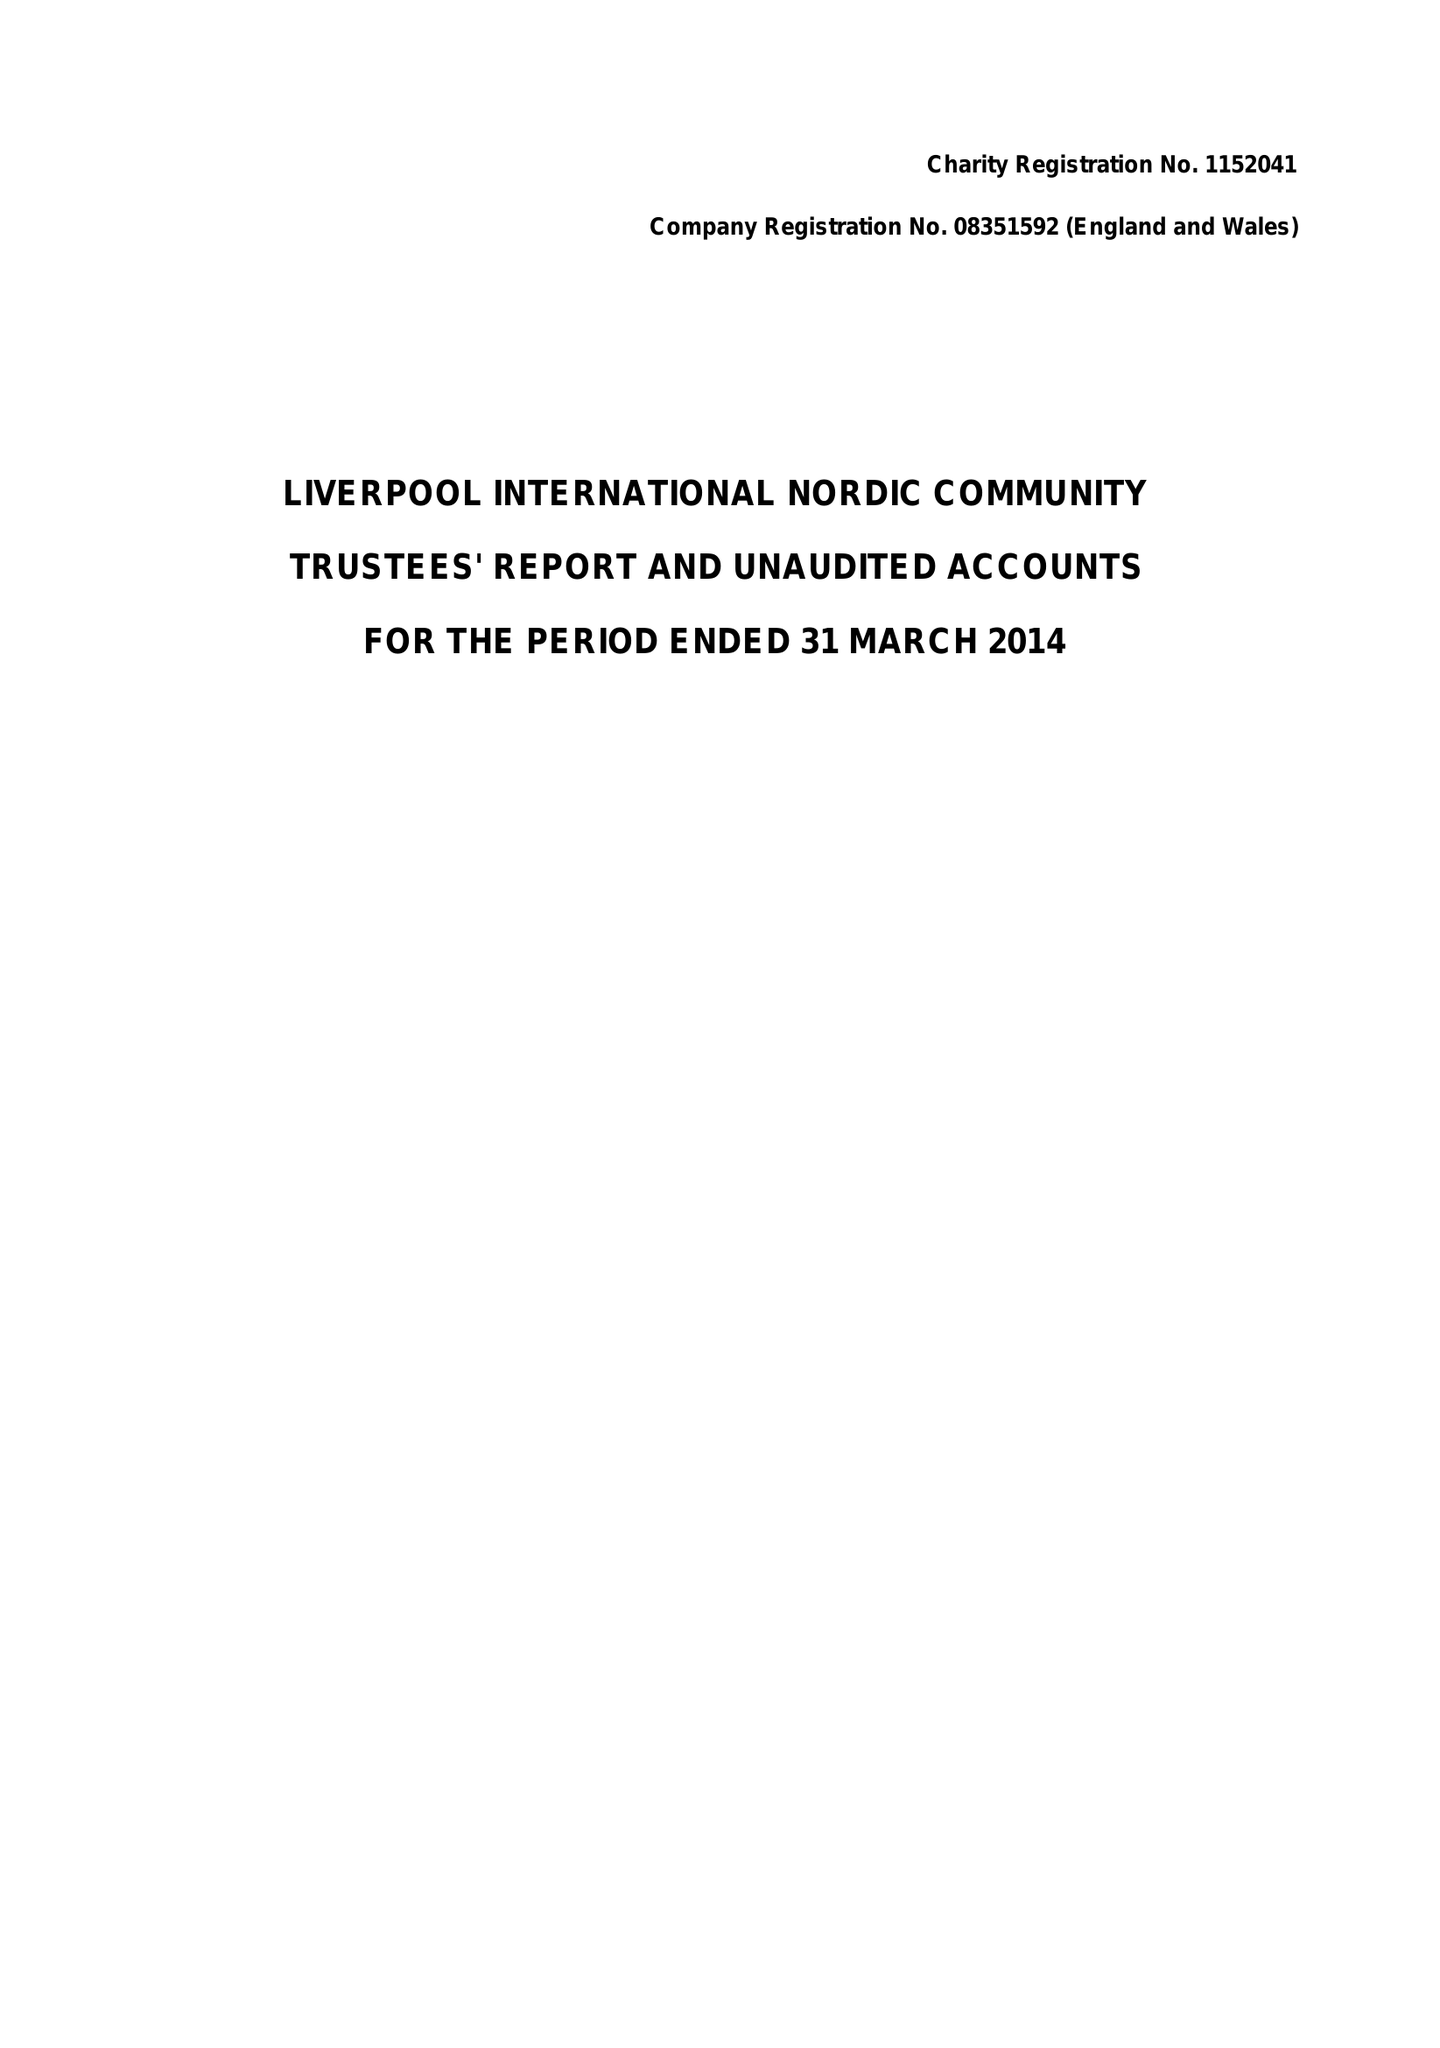What is the value for the address__street_line?
Answer the question using a single word or phrase. 138 PARK LANE 